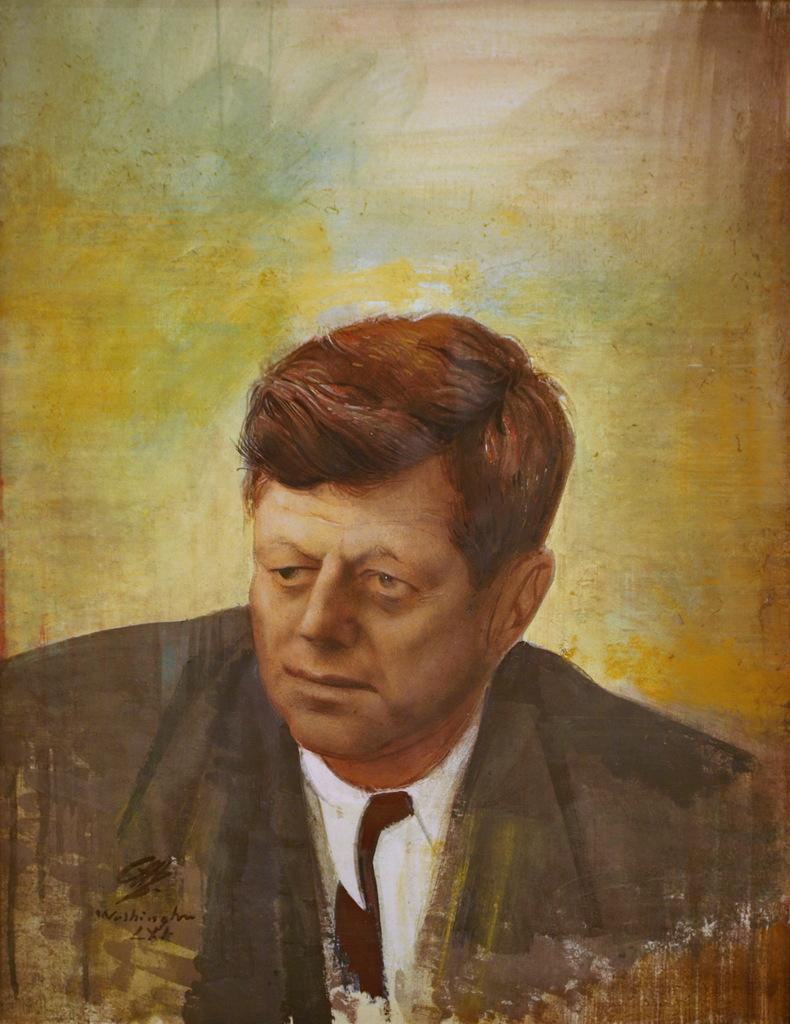What is the main subject of the image? There is a painting in the image. What is depicted in the painting? The painting depicts a man. Can you identify any additional details about the painting? There is a signature in the image. How many cows are present in the painting? There are no cows depicted in the painting; it features a man. What type of maid can be seen attending to the man in the painting? There is no maid present in the painting; it only depicts a man. 